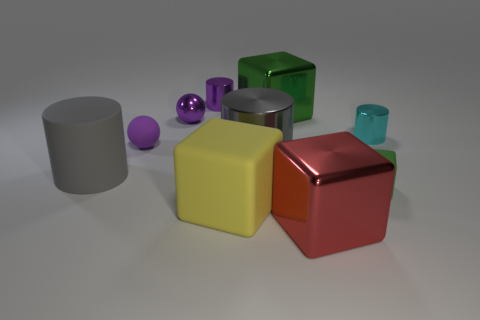The big shiny object behind the cyan object is what color?
Give a very brief answer. Green. What material is the large gray object that is right of the small purple cylinder that is behind the big matte cylinder?
Give a very brief answer. Metal. Are there any gray metallic things of the same size as the gray matte cylinder?
Provide a short and direct response. Yes. How many things are either cubes right of the large rubber block or purple things that are on the left side of the big green block?
Provide a short and direct response. 6. Do the shiny cylinder that is behind the cyan metallic cylinder and the purple object on the left side of the purple metallic ball have the same size?
Make the answer very short. Yes. There is a matte block that is right of the large green metallic thing; is there a matte block in front of it?
Your response must be concise. Yes. How many tiny blocks are behind the small cyan shiny thing?
Your response must be concise. 0. What number of other things are there of the same color as the small rubber ball?
Provide a succinct answer. 2. Are there fewer tiny metallic cylinders in front of the red metallic thing than small things that are behind the small purple rubber object?
Ensure brevity in your answer.  Yes. How many things are metal things right of the red metallic block or purple metal objects?
Offer a terse response. 3. 